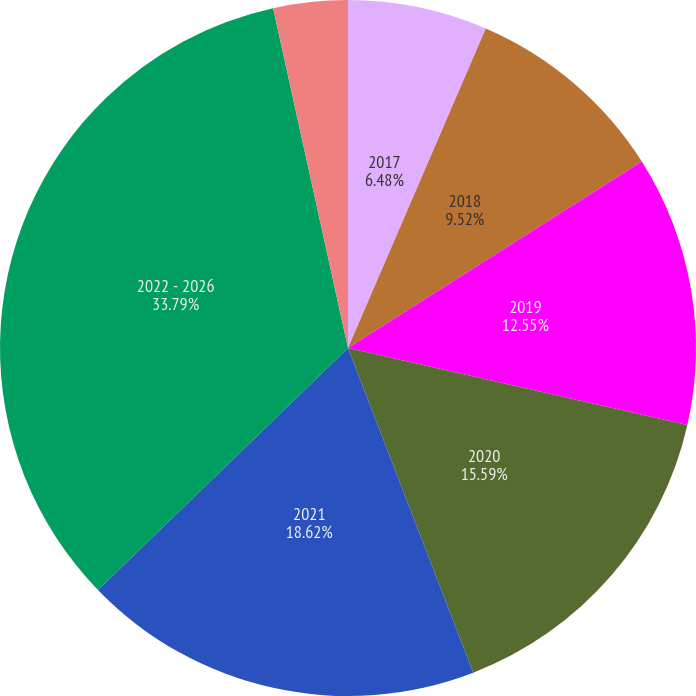Convert chart. <chart><loc_0><loc_0><loc_500><loc_500><pie_chart><fcel>2017<fcel>2018<fcel>2019<fcel>2020<fcel>2021<fcel>2022 - 2026<fcel>Required Company Contributions<nl><fcel>6.48%<fcel>9.52%<fcel>12.55%<fcel>15.59%<fcel>18.62%<fcel>33.79%<fcel>3.45%<nl></chart> 